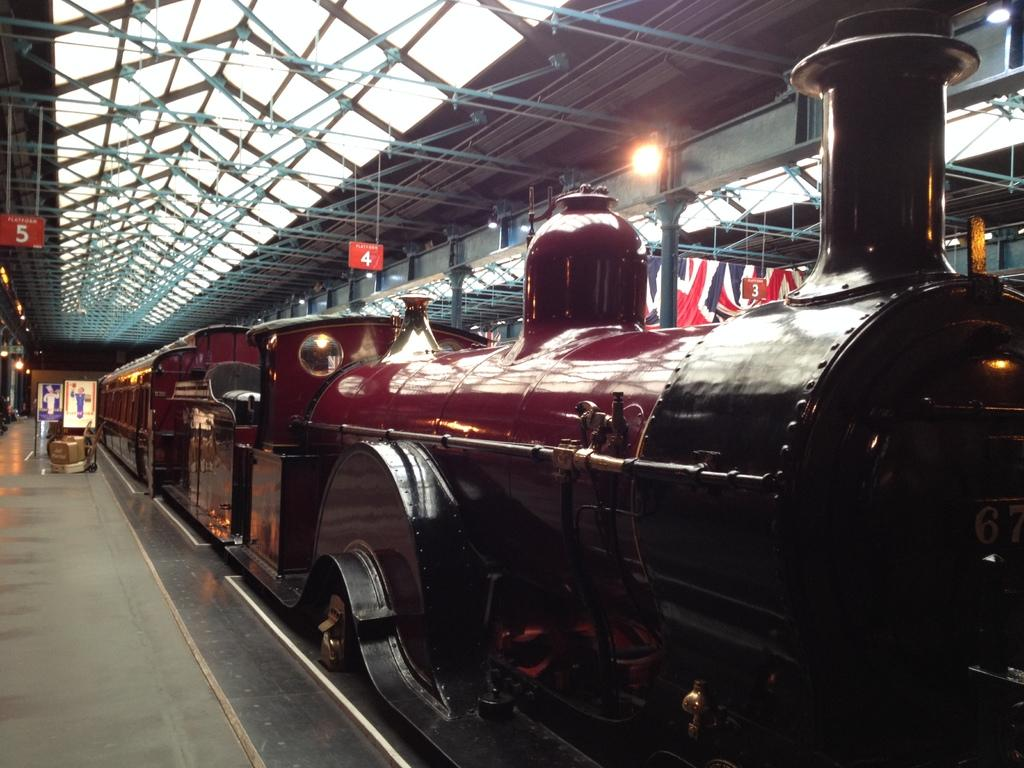What is the main subject of the image? The main subject of the image is a train. What can be seen on the left side of the image? There is a platform with boards on the left side of the image. What objects are present in the image that resemble long, thin bars? There are rods in the image. What type of information is displayed in the image using numerals? Some numbers are hanged in the image. What can be seen in the image that provides illumination? There is light visible in the image. How many fish can be seen swimming near the train in the image? There are no fish present in the image; it features a train and a platform with boards. What type of door is visible on the train in the image? There is no door visible on the train in the image. 